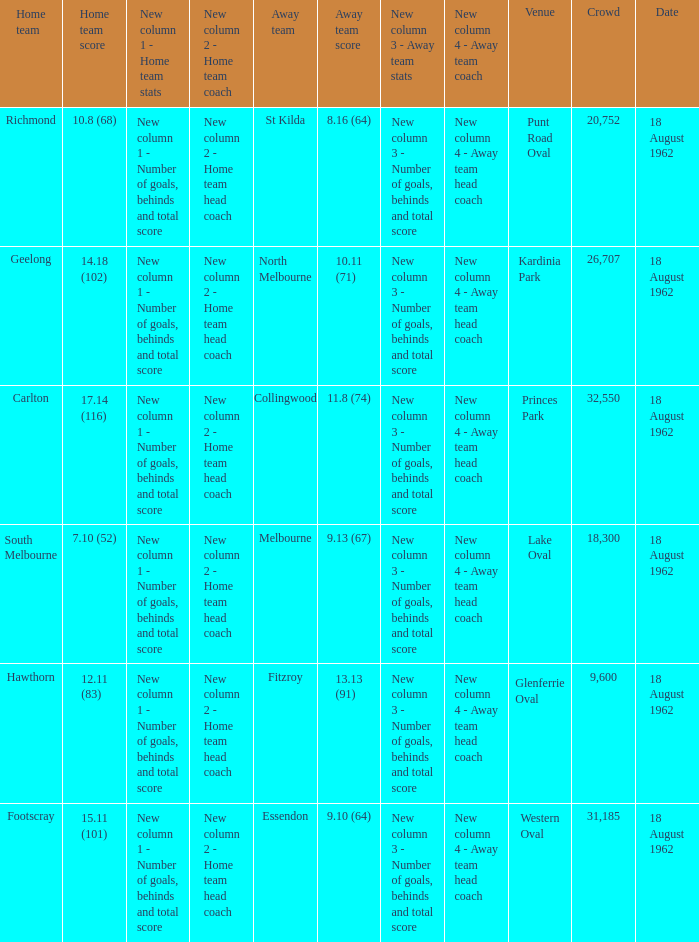Would you mind parsing the complete table? {'header': ['Home team', 'Home team score', 'New column 1 - Home team stats', 'New column 2 - Home team coach', 'Away team', 'Away team score', 'New column 3 - Away team stats', 'New column 4 - Away team coach', 'Venue', 'Crowd', 'Date'], 'rows': [['Richmond', '10.8 (68)', 'New column 1 - Number of goals, behinds and total score', 'New column 2 - Home team head coach', 'St Kilda', '8.16 (64)', 'New column 3 - Number of goals, behinds and total score', 'New column 4 - Away team head coach', 'Punt Road Oval', '20,752', '18 August 1962'], ['Geelong', '14.18 (102)', 'New column 1 - Number of goals, behinds and total score', 'New column 2 - Home team head coach', 'North Melbourne', '10.11 (71)', 'New column 3 - Number of goals, behinds and total score', 'New column 4 - Away team head coach', 'Kardinia Park', '26,707', '18 August 1962'], ['Carlton', '17.14 (116)', 'New column 1 - Number of goals, behinds and total score', 'New column 2 - Home team head coach', 'Collingwood', '11.8 (74)', 'New column 3 - Number of goals, behinds and total score', 'New column 4 - Away team head coach', 'Princes Park', '32,550', '18 August 1962'], ['South Melbourne', '7.10 (52)', 'New column 1 - Number of goals, behinds and total score', 'New column 2 - Home team head coach', 'Melbourne', '9.13 (67)', 'New column 3 - Number of goals, behinds and total score', 'New column 4 - Away team head coach', 'Lake Oval', '18,300', '18 August 1962'], ['Hawthorn', '12.11 (83)', 'New column 1 - Number of goals, behinds and total score', 'New column 2 - Home team head coach', 'Fitzroy', '13.13 (91)', 'New column 3 - Number of goals, behinds and total score', 'New column 4 - Away team head coach', 'Glenferrie Oval', '9,600', '18 August 1962'], ['Footscray', '15.11 (101)', 'New column 1 - Number of goals, behinds and total score', 'New column 2 - Home team head coach', 'Essendon', '9.10 (64)', 'New column 3 - Number of goals, behinds and total score', 'New column 4 - Away team head coach', 'Western Oval', '31,185', '18 August 1962']]} Which stadium had a larger audience than 31,185 when the home team scored 12.11 (83)? None. 